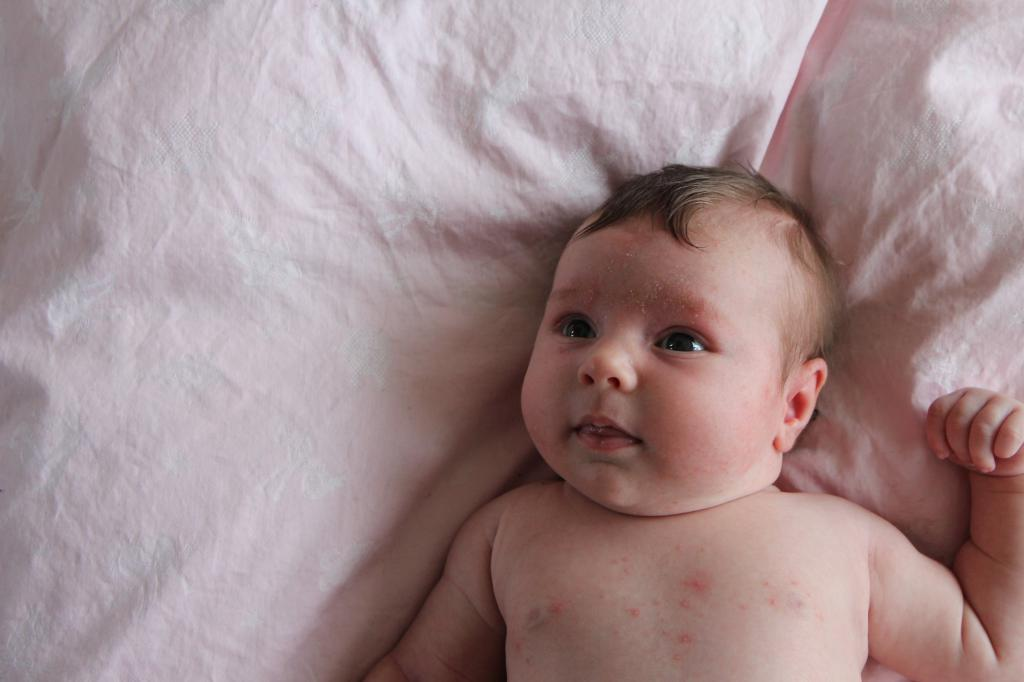What is the main subject of the image? There is a baby lying on a bed in the image. Can you describe the position of the baby in the image? The baby is lying on a bed in the image. What note is the baby playing on the bed in the image? There is no note or musical instrument present in the image; it only shows a baby lying on a bed. 